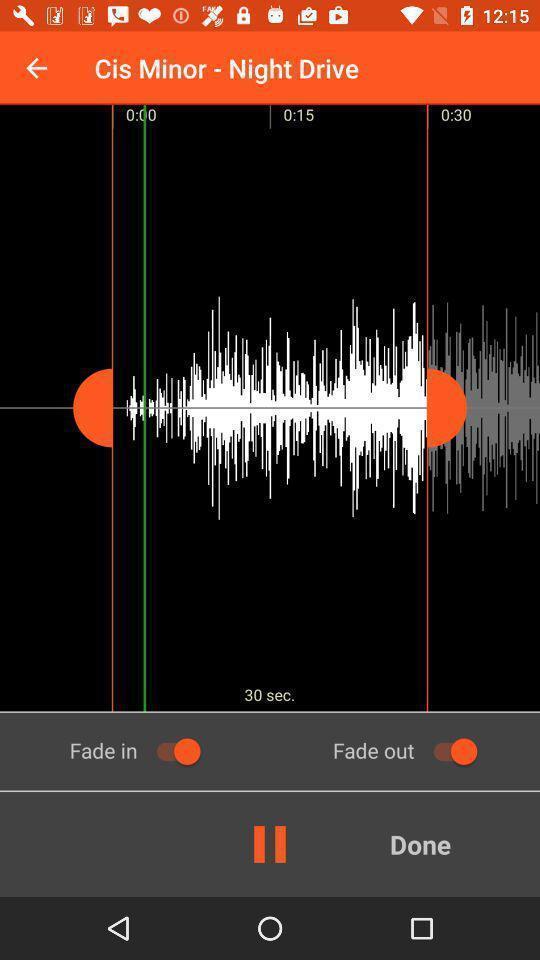Give me a summary of this screen capture. Page shows the audio track playing on ringtone app. 